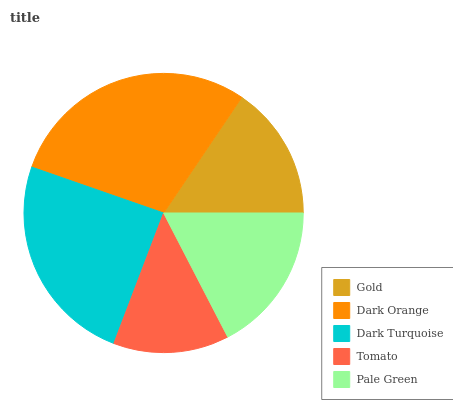Is Tomato the minimum?
Answer yes or no. Yes. Is Dark Orange the maximum?
Answer yes or no. Yes. Is Dark Turquoise the minimum?
Answer yes or no. No. Is Dark Turquoise the maximum?
Answer yes or no. No. Is Dark Orange greater than Dark Turquoise?
Answer yes or no. Yes. Is Dark Turquoise less than Dark Orange?
Answer yes or no. Yes. Is Dark Turquoise greater than Dark Orange?
Answer yes or no. No. Is Dark Orange less than Dark Turquoise?
Answer yes or no. No. Is Pale Green the high median?
Answer yes or no. Yes. Is Pale Green the low median?
Answer yes or no. Yes. Is Dark Turquoise the high median?
Answer yes or no. No. Is Dark Turquoise the low median?
Answer yes or no. No. 